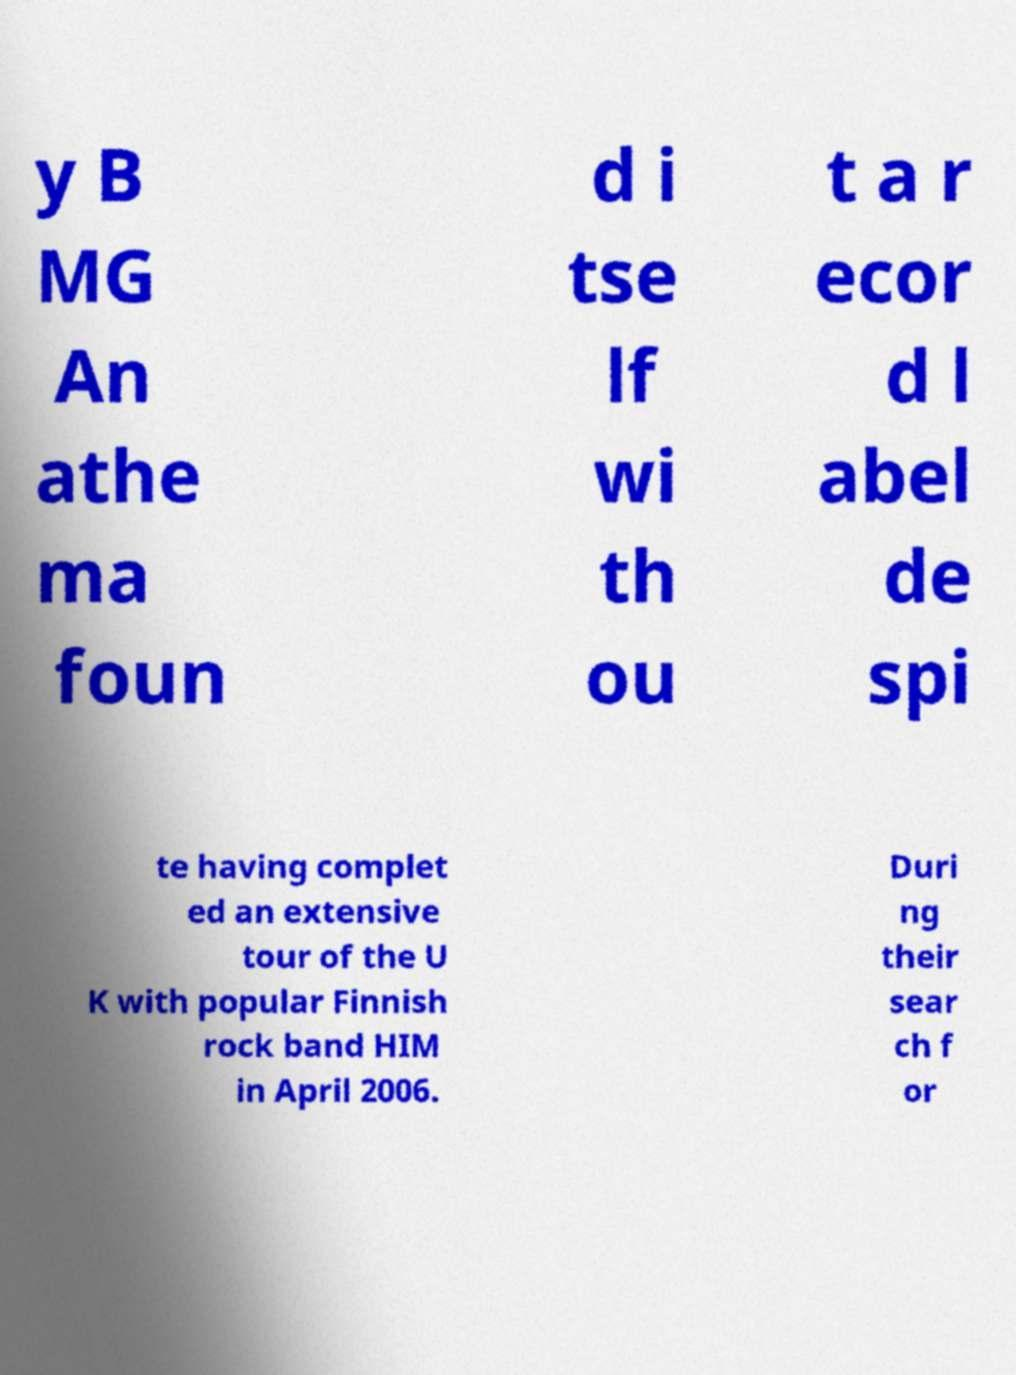I need the written content from this picture converted into text. Can you do that? y B MG An athe ma foun d i tse lf wi th ou t a r ecor d l abel de spi te having complet ed an extensive tour of the U K with popular Finnish rock band HIM in April 2006. Duri ng their sear ch f or 